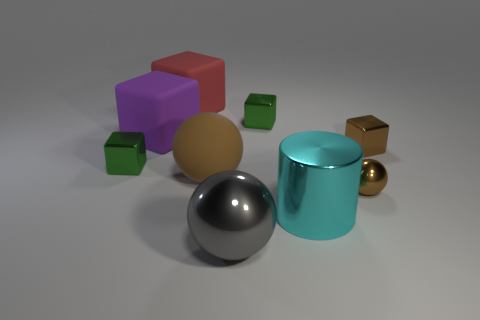Subtract all gray metal spheres. How many spheres are left? 2 Subtract all brown blocks. How many blocks are left? 4 Subtract all blocks. How many objects are left? 4 Subtract 5 blocks. How many blocks are left? 0 Subtract 0 red spheres. How many objects are left? 9 Subtract all gray spheres. Subtract all purple cylinders. How many spheres are left? 2 Subtract all yellow blocks. How many brown balls are left? 2 Subtract all big brown spheres. Subtract all small balls. How many objects are left? 7 Add 5 shiny cylinders. How many shiny cylinders are left? 6 Add 6 small metal things. How many small metal things exist? 10 